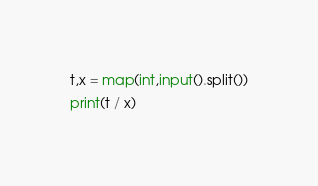Convert code to text. <code><loc_0><loc_0><loc_500><loc_500><_Python_>t,x = map(int,input().split())
print(t / x)</code> 